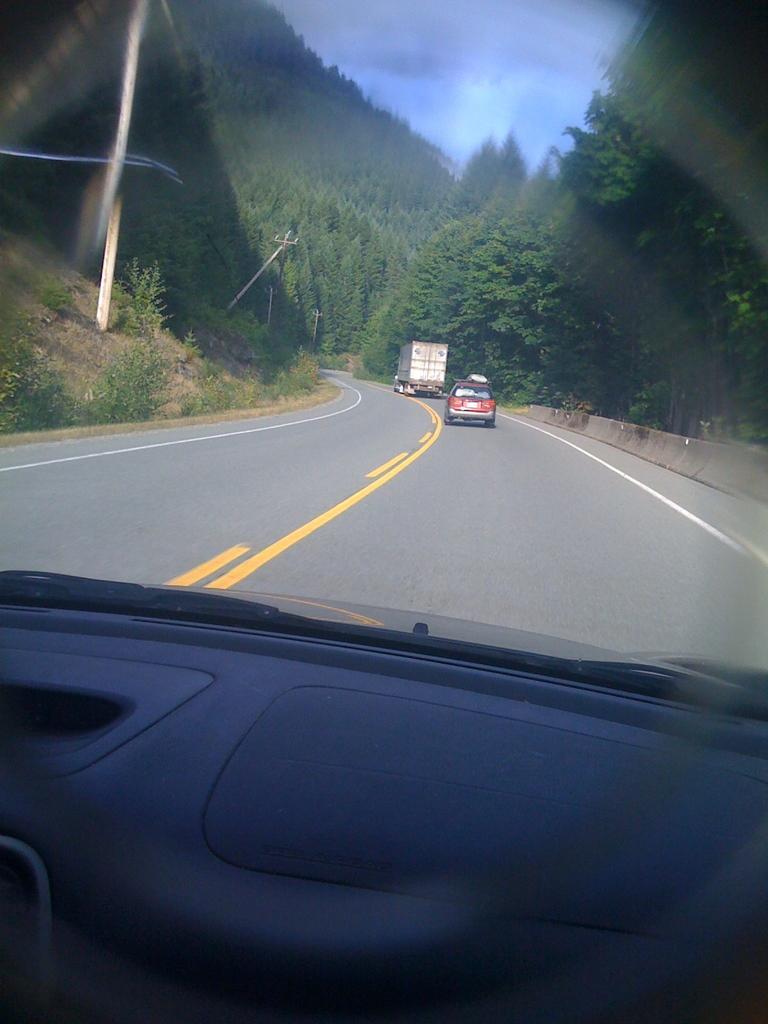Could you give a brief overview of what you see in this image? In this picture there is view from the inside of a car. In the front there is a road on which one red color car and white truck is moving on the road. Behind there are huge trees around the road. 